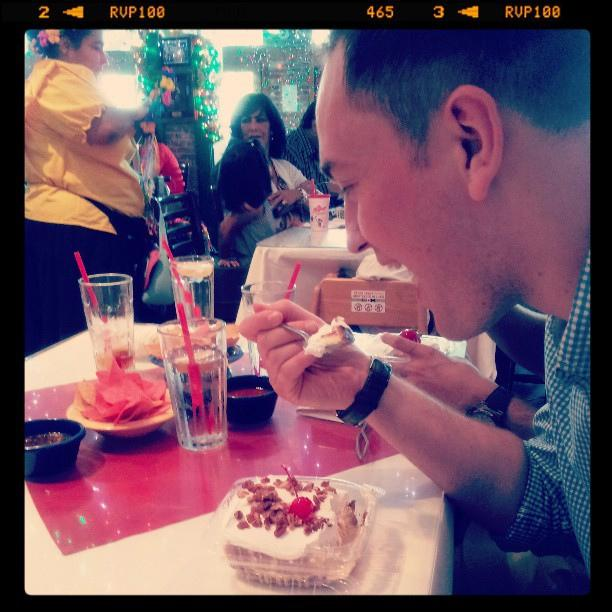What is the red object in the food the man is eating? cherry 